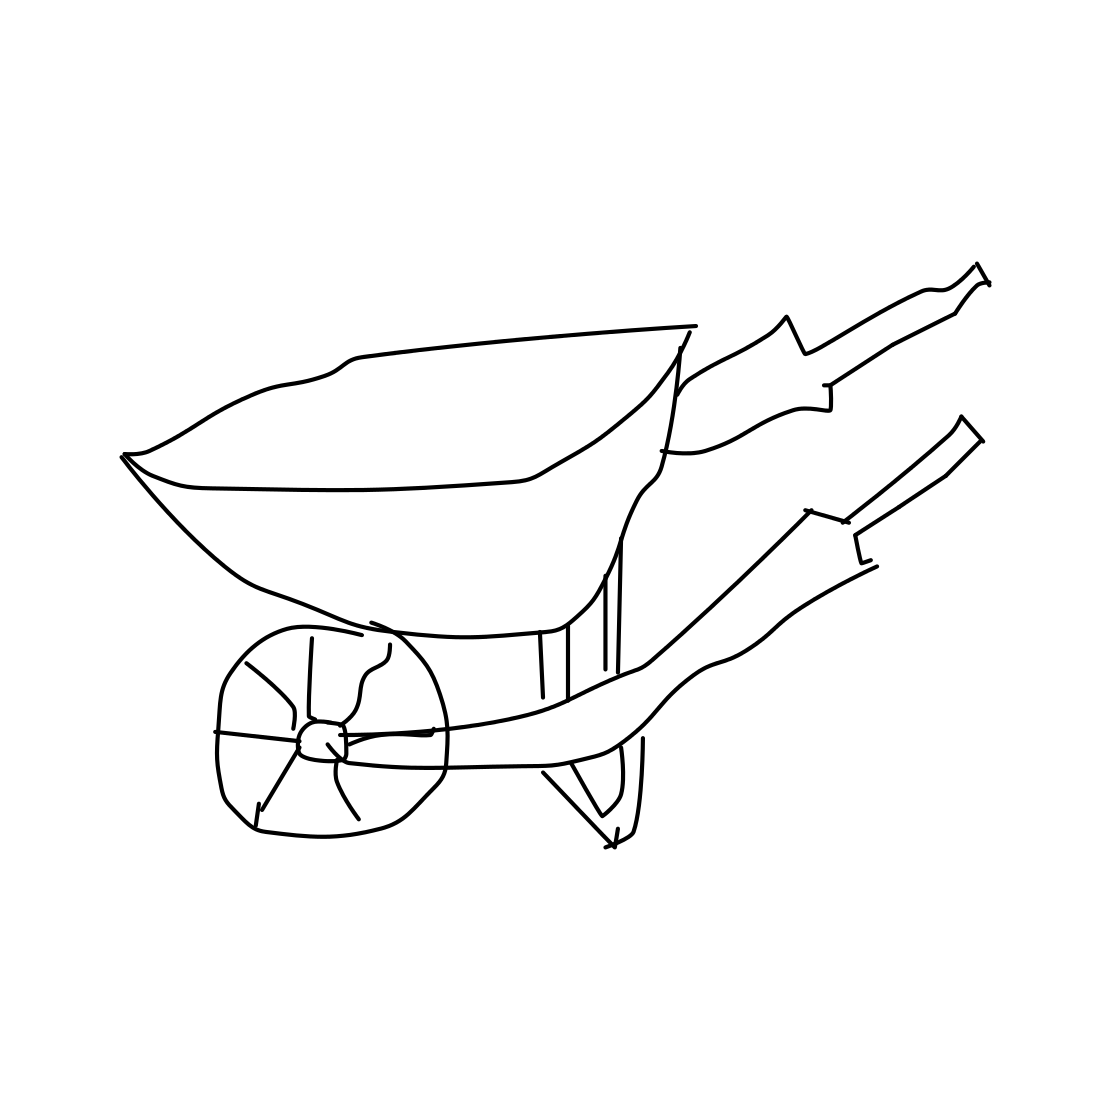What material seems to be used for the wheelbarrow in this image? Based on the image, the wheelbarrow appears to be made of metal, probably steel, which is a sturdy and reliable material for such a tool. Its durability ensures that it can handle heavy loads and resist damage from rough or sharp materials.  Is the wheel of the wheelbarrow solid or might it be inflatable? From this image, it's a bit challenging to determine definitively whether the wheel is solid or inflatable. However, most wheelbarrows have inflatable pneumatic wheels to absorb shock and provide smoother handling over uneven terrain. If this wheelbarrow is intended for general use, it's likely to have an inflatable wheel. 